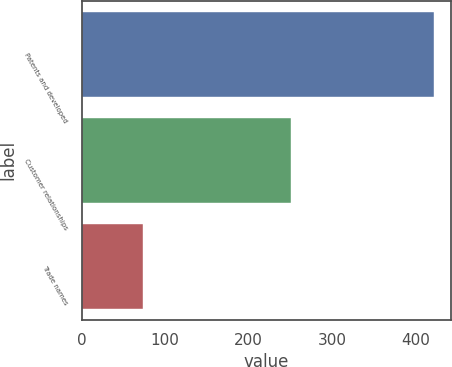Convert chart. <chart><loc_0><loc_0><loc_500><loc_500><bar_chart><fcel>Patents and developed<fcel>Customer relationships<fcel>Trade names<nl><fcel>422<fcel>251<fcel>73<nl></chart> 